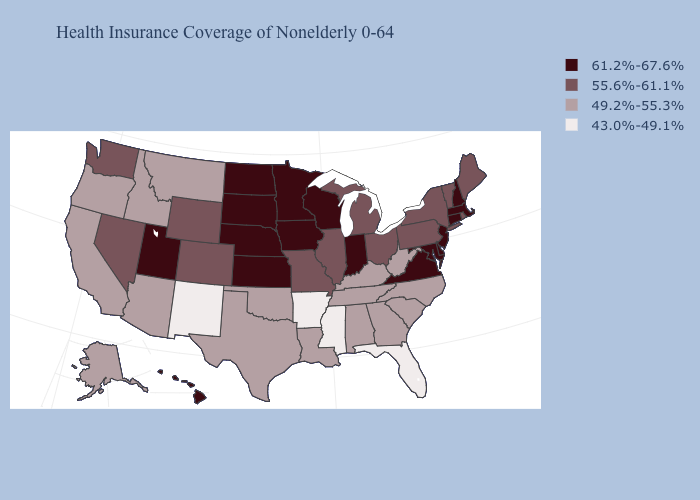Name the states that have a value in the range 43.0%-49.1%?
Keep it brief. Arkansas, Florida, Mississippi, New Mexico. What is the lowest value in the West?
Concise answer only. 43.0%-49.1%. What is the lowest value in the MidWest?
Be succinct. 55.6%-61.1%. What is the value of Ohio?
Concise answer only. 55.6%-61.1%. Does Oklahoma have the same value as South Carolina?
Keep it brief. Yes. What is the value of Maryland?
Answer briefly. 61.2%-67.6%. What is the value of West Virginia?
Give a very brief answer. 49.2%-55.3%. Is the legend a continuous bar?
Answer briefly. No. What is the value of Mississippi?
Be succinct. 43.0%-49.1%. Name the states that have a value in the range 55.6%-61.1%?
Write a very short answer. Colorado, Illinois, Maine, Michigan, Missouri, Nevada, New York, Ohio, Pennsylvania, Rhode Island, Vermont, Washington, Wyoming. What is the lowest value in the MidWest?
Keep it brief. 55.6%-61.1%. Among the states that border Colorado , does Nebraska have the highest value?
Short answer required. Yes. Which states hav the highest value in the West?
Give a very brief answer. Hawaii, Utah. Does Alaska have the highest value in the USA?
Short answer required. No. Does Arizona have the same value as New York?
Quick response, please. No. 